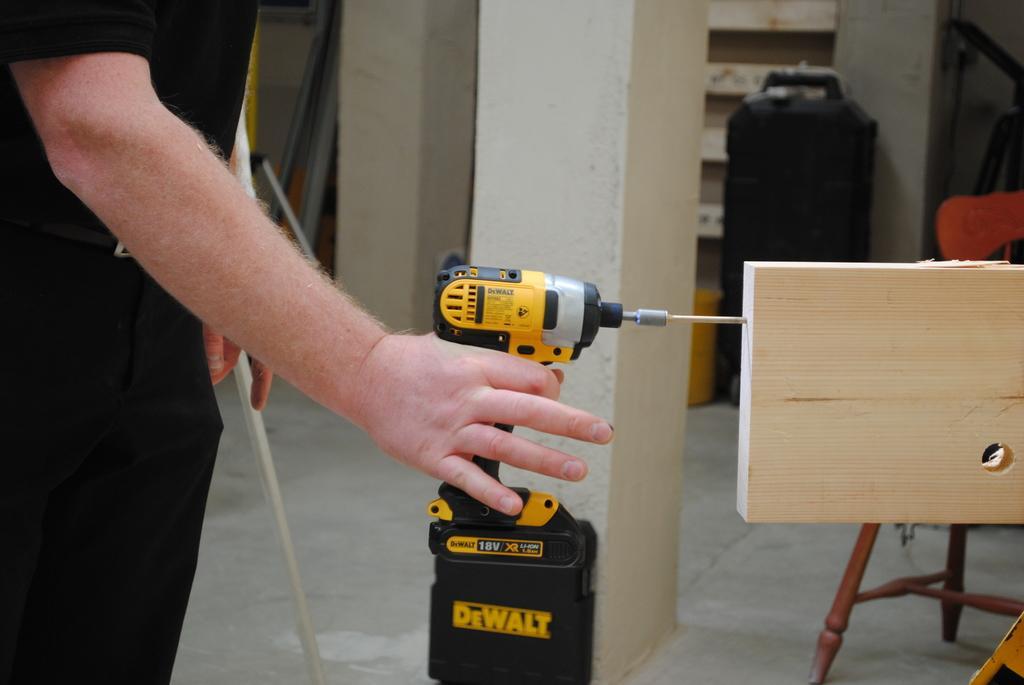Please provide a concise description of this image. This picture is clicked inside. On the left corner there is a person holding a machine and standing on the ground. On the right we can see a wooden plank and a chair which is placed on the ground. In the center there is a pillar. In the background we can see there are some objects placed on the ground and we can see the wall. 